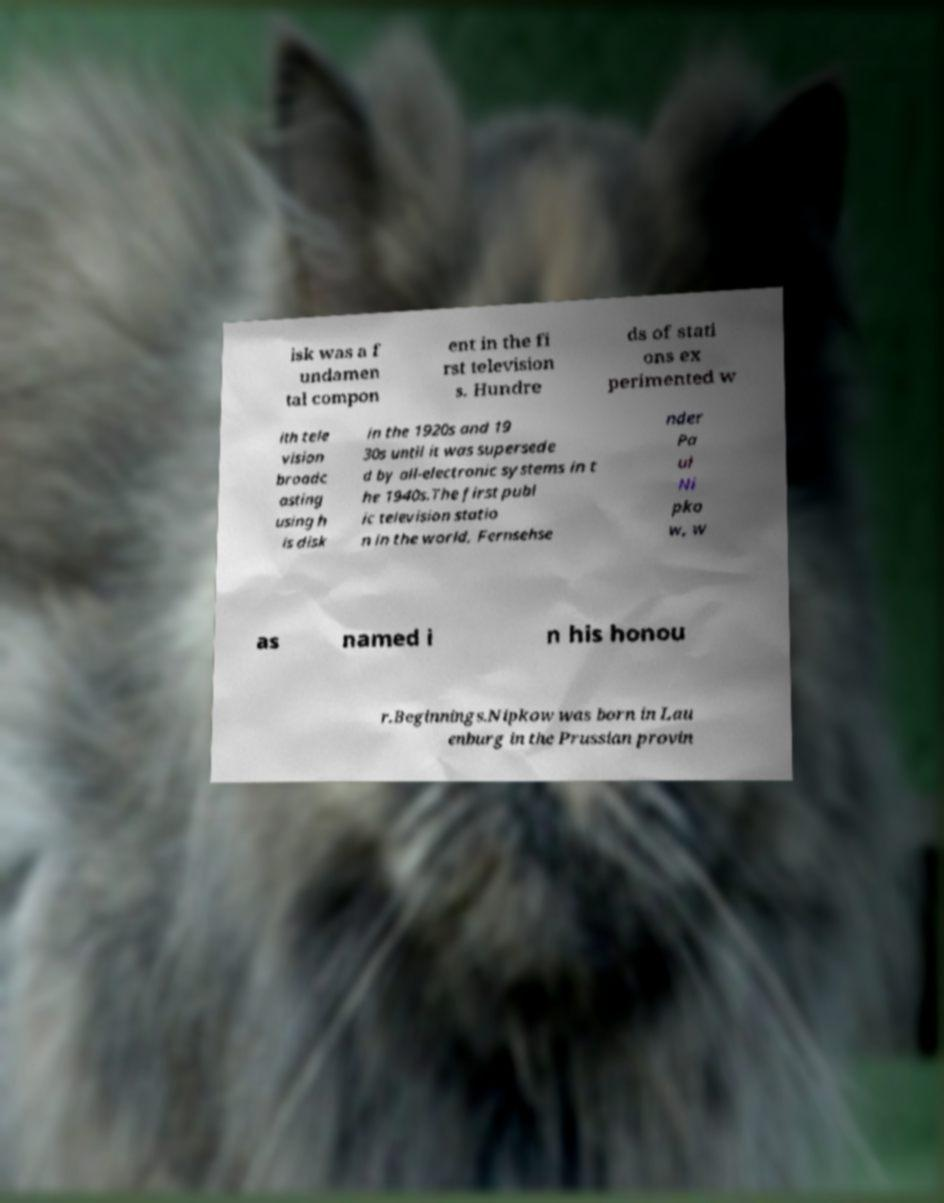Could you extract and type out the text from this image? isk was a f undamen tal compon ent in the fi rst television s. Hundre ds of stati ons ex perimented w ith tele vision broadc asting using h is disk in the 1920s and 19 30s until it was supersede d by all-electronic systems in t he 1940s.The first publ ic television statio n in the world, Fernsehse nder Pa ul Ni pko w, w as named i n his honou r.Beginnings.Nipkow was born in Lau enburg in the Prussian provin 